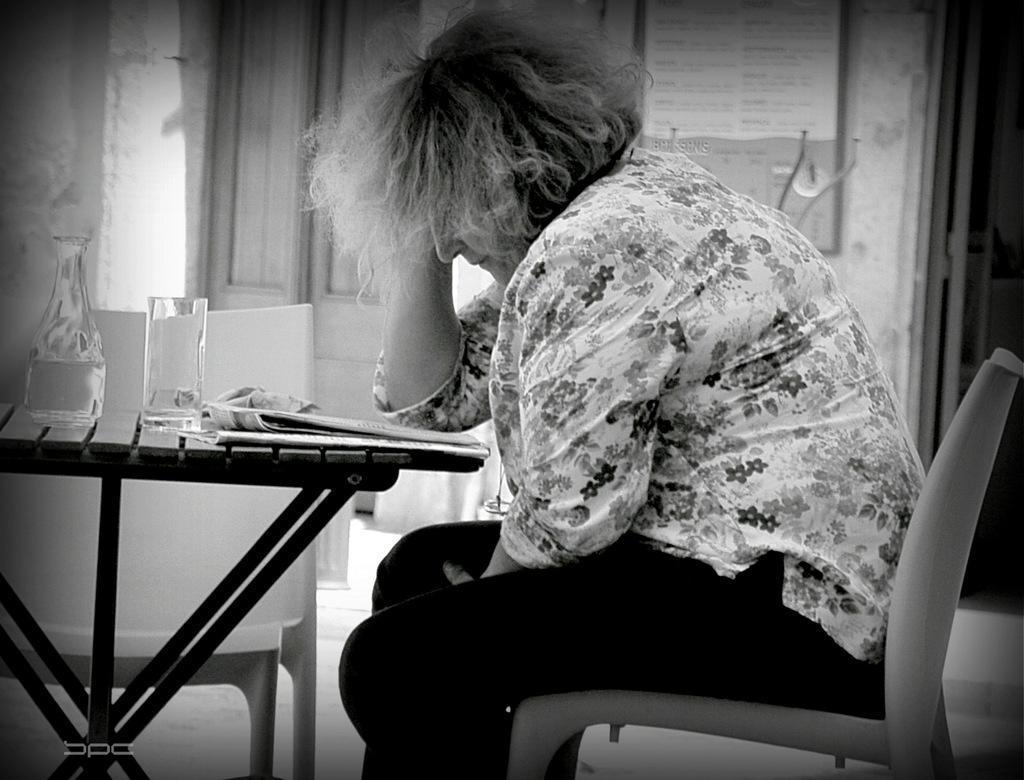What is the color scheme of the image? The image is black and white. What piece of furniture can be seen in the image? There is a small table in the image. What items are on the table? A water bottle, a tumbler, and a newspaper are on the table. What is the woman in the image doing? The woman is sitting on a chair in the image. What type of instrument is the woman playing in the image? There is no instrument present in the image, and the woman is not playing any instrument. Can you see a brush on the table in the image? No, there is no brush on the table in the image. 